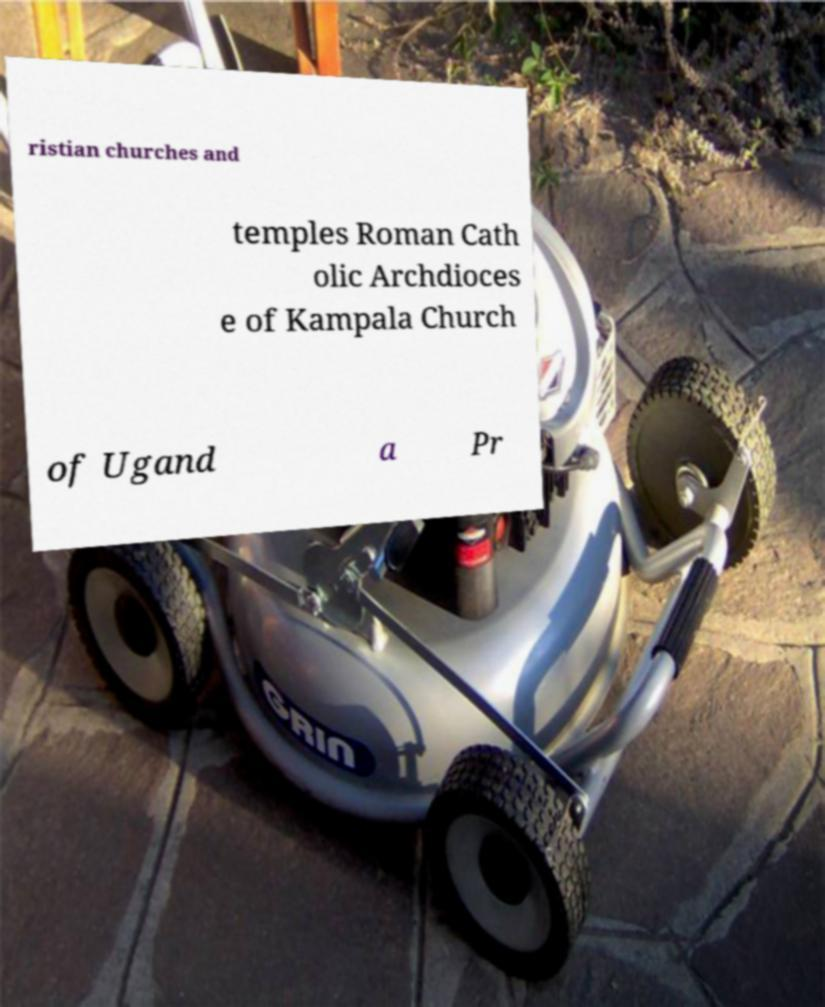Please identify and transcribe the text found in this image. ristian churches and temples Roman Cath olic Archdioces e of Kampala Church of Ugand a Pr 